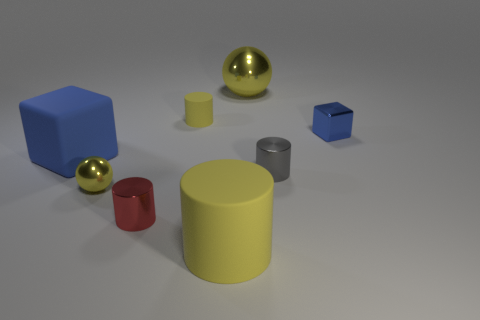Add 1 big metallic things. How many objects exist? 9 Subtract all tiny yellow matte cylinders. How many cylinders are left? 3 Subtract 2 blocks. How many blocks are left? 0 Subtract all yellow balls. How many purple cubes are left? 0 Subtract all metal blocks. Subtract all small metallic cylinders. How many objects are left? 5 Add 8 shiny balls. How many shiny balls are left? 10 Add 5 small yellow matte objects. How many small yellow matte objects exist? 6 Subtract all yellow cylinders. How many cylinders are left? 2 Subtract 0 cyan spheres. How many objects are left? 8 Subtract all cubes. How many objects are left? 6 